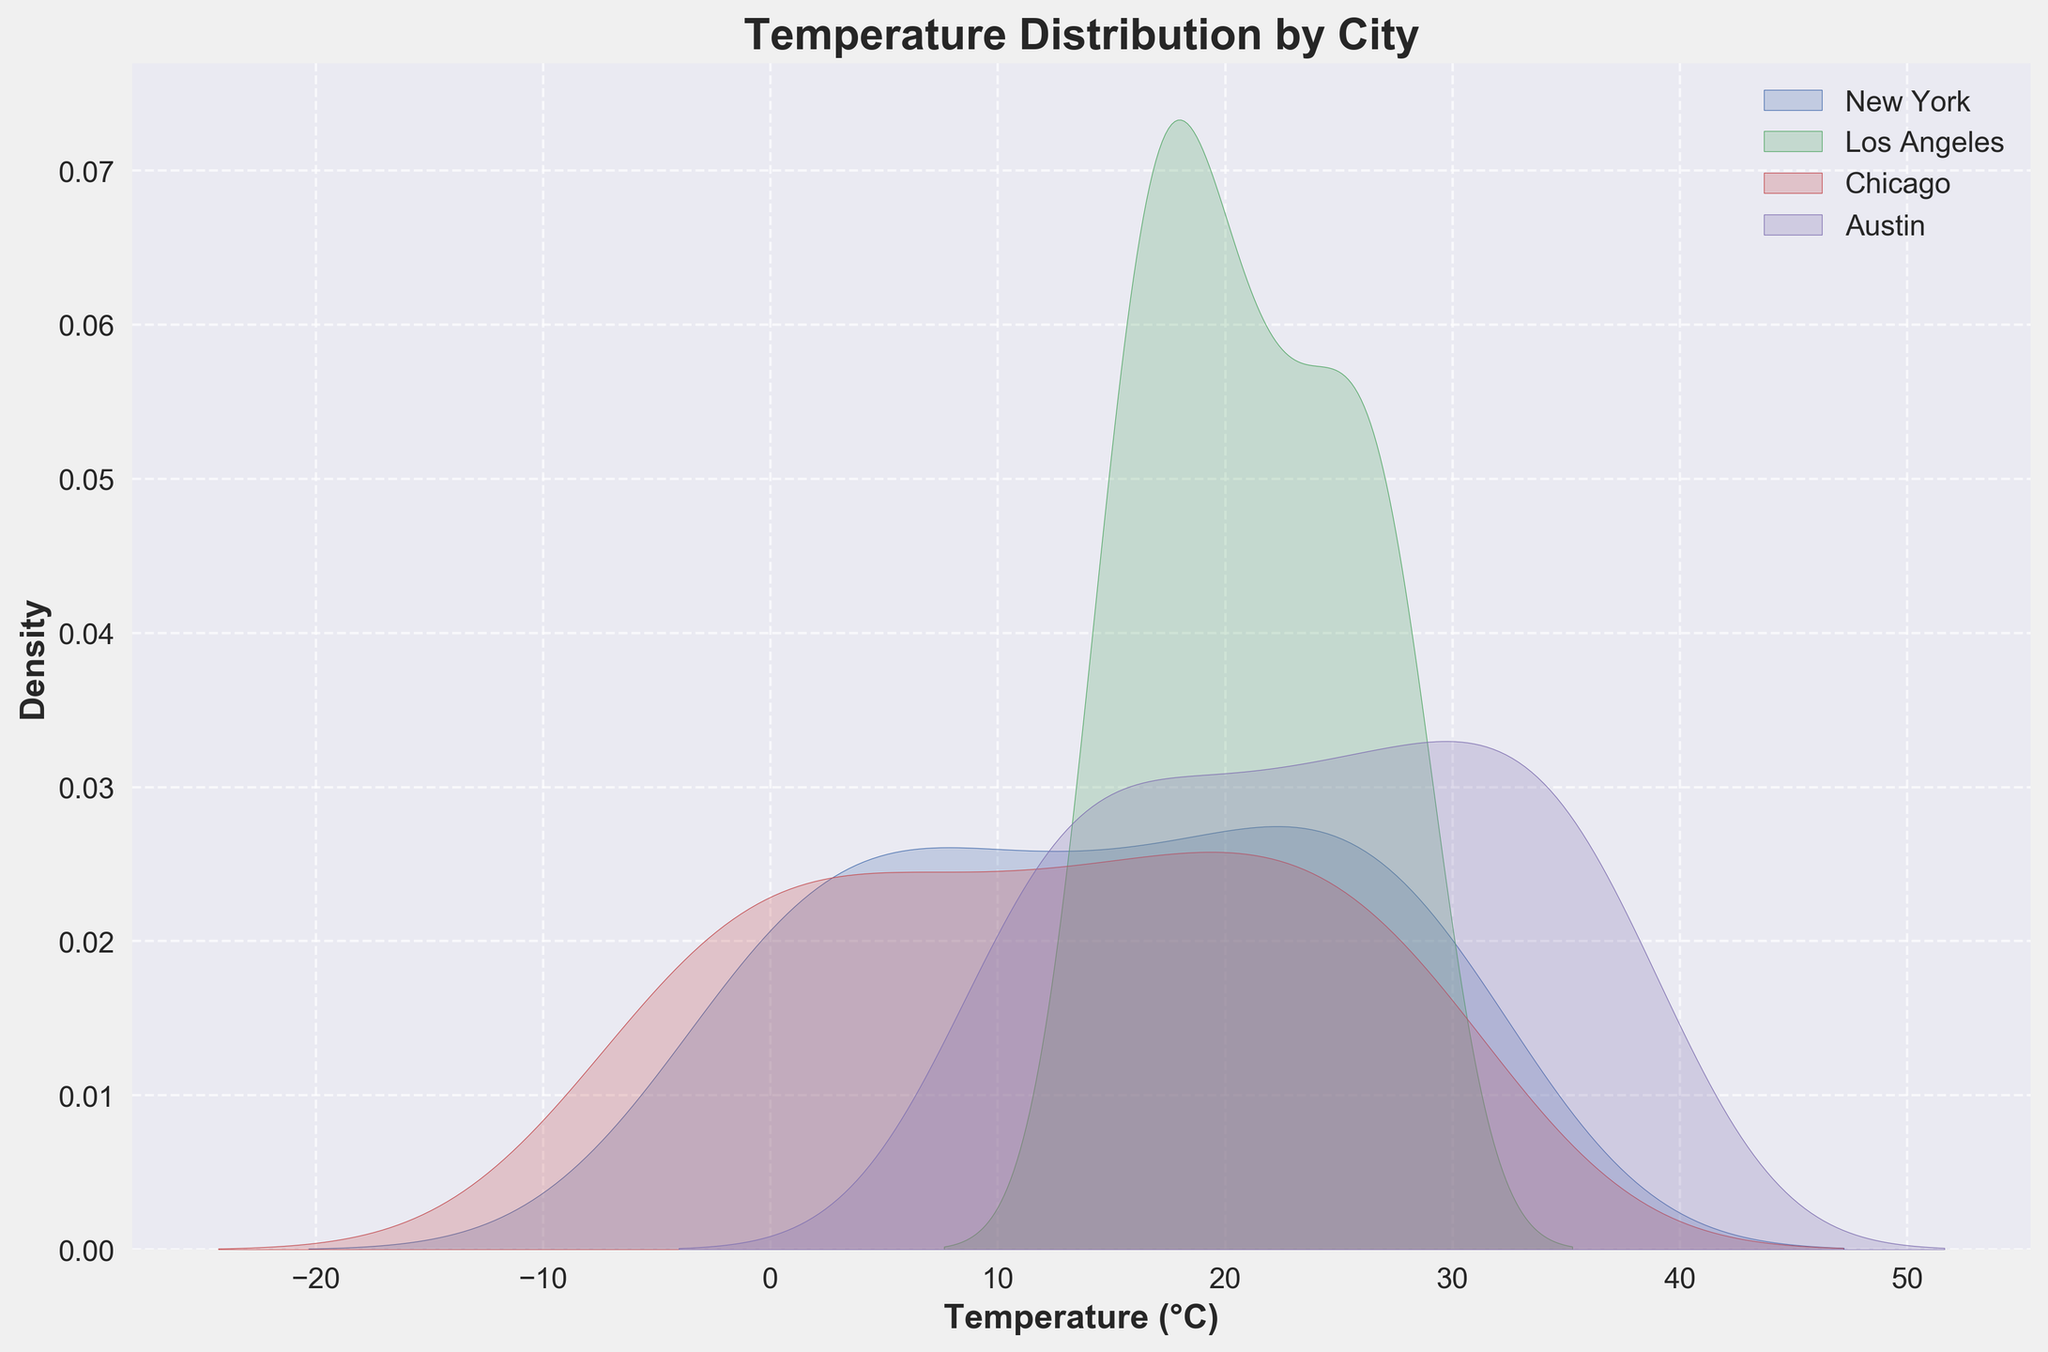What is the title of the plot? The title of the plot is displayed prominently at the top. It provides a context for what the plot is about.
Answer: Temperature Distribution by City How are the axes labeled? The labels for the axes are recorded at the edges of each axis. These labels explain what each axis represents. The x-axis is labeled 'Temperature (°C)' and the y-axis is labeled 'Density'.
Answer: 'Temperature (°C)' and 'Density' Which city shows the highest peak in the temperature density plot? By examining the height of the density peaks for each city, we can identify which city has the highest peak. The city with the highest peak in the density plot indicates the most frequent temperature range.
Answer: Austin Between which temperature ranges does New York see the highest density? Look at the density curve for New York and identify the temperature range that corresponds to the highest part of the curve. The highest density area represents the most common temperature range for New York.
Answer: 22°C to 24°C How does the temperature density curve for Los Angeles differ from that of Chicago? Compare the general shapes of the curves for Los Angeles and Chicago. Differences in the spread, height, and position of the peaks provide insights into how their temperature distributions differ.
Answer: Los Angeles has a narrower spread and higher peak around 17-20°C, while Chicago has a broader spread with peaks near -10°C to 30°C Which city has the broadest temperature range? The broadest temperature range would be visible as the city with the widest spread in its density plot.
Answer: Chicago Does any city have multiple peaks in their temperature distribution? Observing the density plots for multiple peaks (bimodal, multimodal) will indicate if a city has more than one frequent temperature range.
Answer: No Compare the median temperature values of New York and Austin. To compare the median values, look for the point where each city's density curve balances, as the median splits the data into two equal halves. Identify these median positions visually on the x-axis.
Answer: New York has a lower median temperature than Austin During which temperature range is the overlap between Los Angeles and New York's densities most significant? Examine where the density curves for Los Angeles and New York intersect and the area of overlap. The most significant overlap occurs in the temperature range where both density plots share a high value.
Answer: 22°C to 24°C 